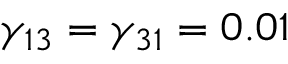Convert formula to latex. <formula><loc_0><loc_0><loc_500><loc_500>\gamma _ { 1 3 } = \gamma _ { 3 1 } = 0 . 0 1</formula> 